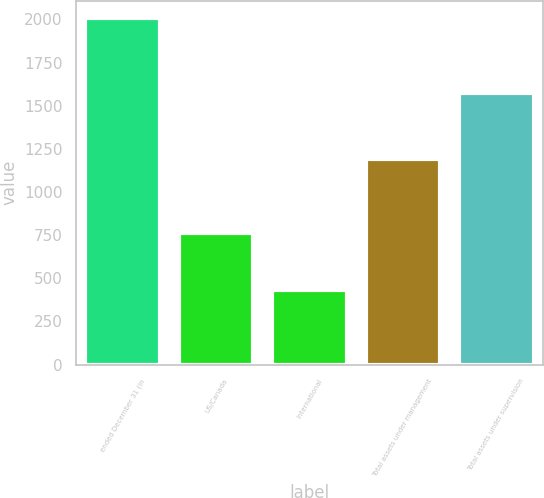Convert chart to OTSL. <chart><loc_0><loc_0><loc_500><loc_500><bar_chart><fcel>ended December 31 (in<fcel>US/Canada<fcel>International<fcel>Total assets under management<fcel>Total assets under supervision<nl><fcel>2007<fcel>760<fcel>433<fcel>1193<fcel>1572<nl></chart> 